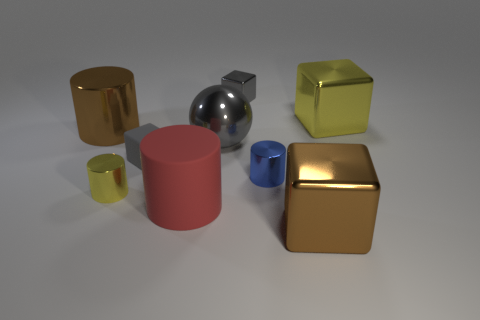Subtract all yellow metallic cylinders. How many cylinders are left? 3 Subtract all red cylinders. How many cylinders are left? 3 Add 1 tiny blue matte objects. How many objects exist? 10 Subtract 1 spheres. How many spheres are left? 0 Subtract all brown spheres. How many yellow blocks are left? 1 Add 8 small yellow objects. How many small yellow objects are left? 9 Add 8 brown metallic cubes. How many brown metallic cubes exist? 9 Subtract 1 gray cubes. How many objects are left? 8 Subtract all spheres. How many objects are left? 8 Subtract all yellow spheres. Subtract all red cubes. How many spheres are left? 1 